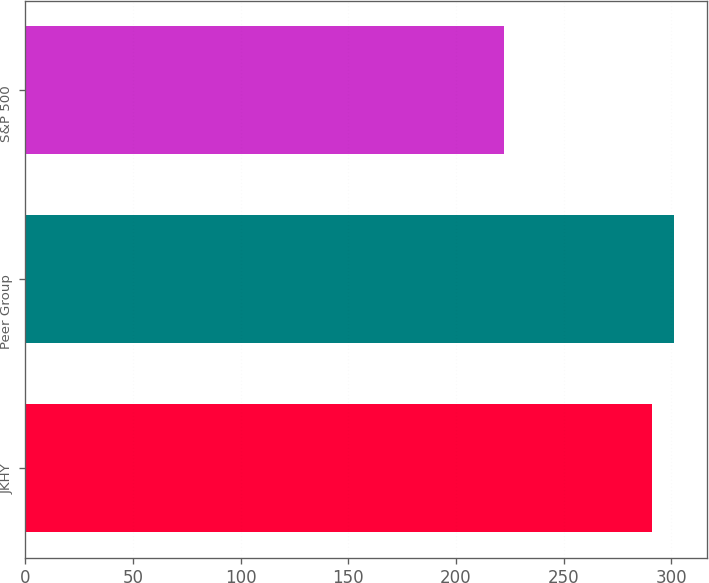<chart> <loc_0><loc_0><loc_500><loc_500><bar_chart><fcel>JKHY<fcel>Peer Group<fcel>S&P 500<nl><fcel>290.88<fcel>301.34<fcel>222.47<nl></chart> 